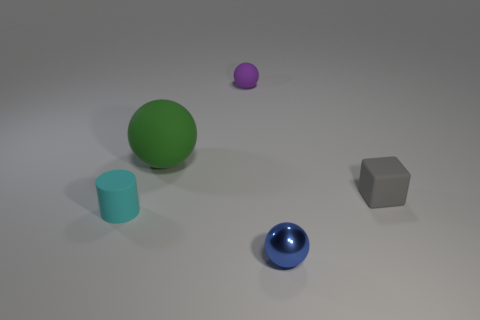Is there anything else that is made of the same material as the blue object?
Ensure brevity in your answer.  No. What is the color of the thing that is both in front of the purple matte thing and behind the gray cube?
Give a very brief answer. Green. How many balls are either tiny objects or cyan metallic objects?
Give a very brief answer. 2. Are there fewer gray matte things that are in front of the large green matte object than big rubber objects?
Provide a succinct answer. No. What is the shape of the big thing that is the same material as the gray block?
Provide a succinct answer. Sphere. How many things are small red metallic cylinders or purple rubber objects?
Give a very brief answer. 1. There is a tiny ball in front of the thing to the right of the metallic ball; what is it made of?
Give a very brief answer. Metal. Is there a large object made of the same material as the green ball?
Provide a short and direct response. No. The small thing that is left of the tiny purple thing behind the small object that is on the right side of the shiny ball is what shape?
Provide a short and direct response. Cylinder. What material is the purple sphere?
Offer a very short reply. Rubber. 